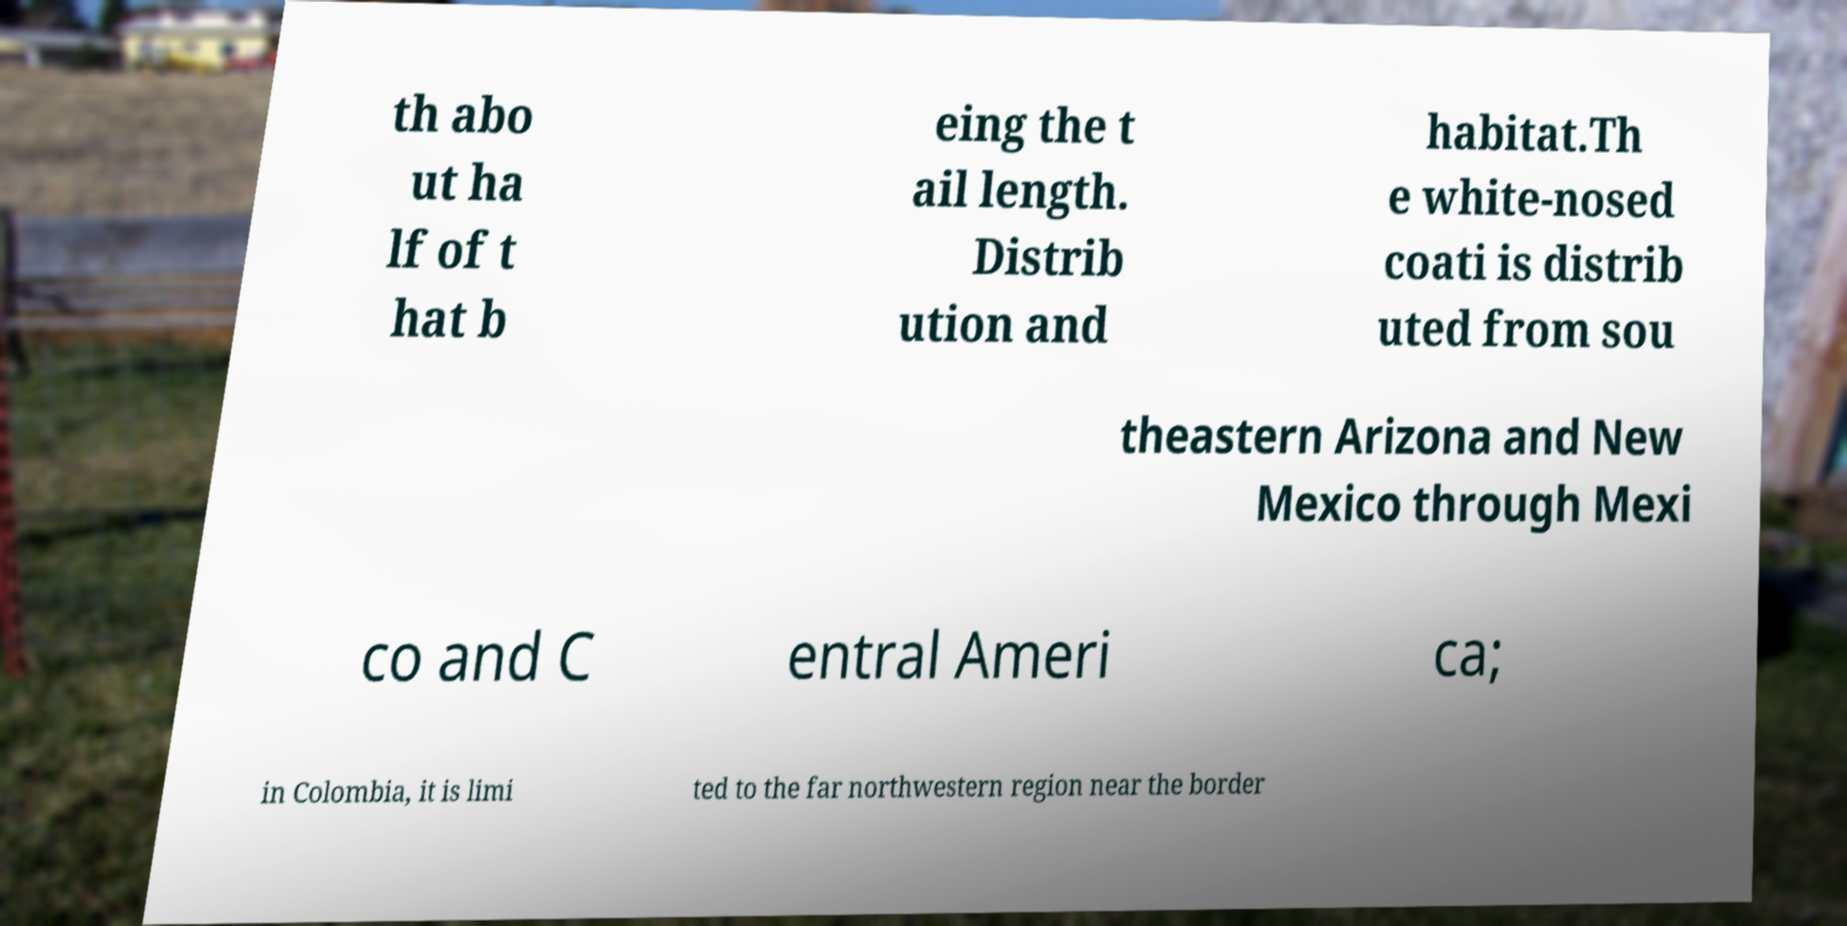There's text embedded in this image that I need extracted. Can you transcribe it verbatim? th abo ut ha lf of t hat b eing the t ail length. Distrib ution and habitat.Th e white-nosed coati is distrib uted from sou theastern Arizona and New Mexico through Mexi co and C entral Ameri ca; in Colombia, it is limi ted to the far northwestern region near the border 